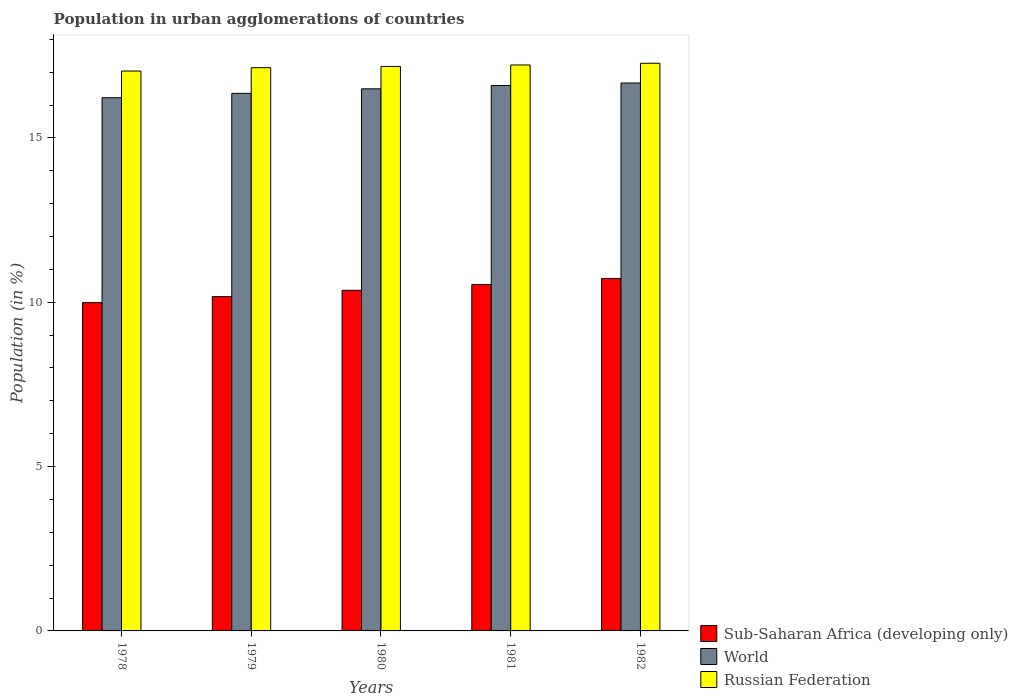Are the number of bars per tick equal to the number of legend labels?
Offer a terse response. Yes. Are the number of bars on each tick of the X-axis equal?
Offer a very short reply. Yes. What is the label of the 2nd group of bars from the left?
Make the answer very short. 1979. In how many cases, is the number of bars for a given year not equal to the number of legend labels?
Ensure brevity in your answer.  0. What is the percentage of population in urban agglomerations in World in 1982?
Keep it short and to the point. 16.67. Across all years, what is the maximum percentage of population in urban agglomerations in World?
Offer a terse response. 16.67. Across all years, what is the minimum percentage of population in urban agglomerations in Sub-Saharan Africa (developing only)?
Ensure brevity in your answer.  9.99. In which year was the percentage of population in urban agglomerations in World minimum?
Make the answer very short. 1978. What is the total percentage of population in urban agglomerations in World in the graph?
Give a very brief answer. 82.33. What is the difference between the percentage of population in urban agglomerations in Sub-Saharan Africa (developing only) in 1979 and that in 1981?
Keep it short and to the point. -0.37. What is the difference between the percentage of population in urban agglomerations in Sub-Saharan Africa (developing only) in 1982 and the percentage of population in urban agglomerations in Russian Federation in 1978?
Your answer should be compact. -6.31. What is the average percentage of population in urban agglomerations in Sub-Saharan Africa (developing only) per year?
Your answer should be compact. 10.36. In the year 1980, what is the difference between the percentage of population in urban agglomerations in World and percentage of population in urban agglomerations in Russian Federation?
Provide a short and direct response. -0.68. In how many years, is the percentage of population in urban agglomerations in Sub-Saharan Africa (developing only) greater than 6 %?
Offer a very short reply. 5. What is the ratio of the percentage of population in urban agglomerations in World in 1980 to that in 1982?
Provide a short and direct response. 0.99. Is the difference between the percentage of population in urban agglomerations in World in 1981 and 1982 greater than the difference between the percentage of population in urban agglomerations in Russian Federation in 1981 and 1982?
Make the answer very short. No. What is the difference between the highest and the second highest percentage of population in urban agglomerations in World?
Offer a very short reply. 0.08. What is the difference between the highest and the lowest percentage of population in urban agglomerations in Russian Federation?
Give a very brief answer. 0.24. In how many years, is the percentage of population in urban agglomerations in Sub-Saharan Africa (developing only) greater than the average percentage of population in urban agglomerations in Sub-Saharan Africa (developing only) taken over all years?
Provide a short and direct response. 3. What does the 2nd bar from the left in 1978 represents?
Your response must be concise. World. What does the 1st bar from the right in 1981 represents?
Make the answer very short. Russian Federation. How many bars are there?
Offer a terse response. 15. How many years are there in the graph?
Offer a very short reply. 5. What is the difference between two consecutive major ticks on the Y-axis?
Your answer should be compact. 5. Are the values on the major ticks of Y-axis written in scientific E-notation?
Your answer should be compact. No. How are the legend labels stacked?
Provide a succinct answer. Vertical. What is the title of the graph?
Provide a short and direct response. Population in urban agglomerations of countries. What is the label or title of the Y-axis?
Offer a terse response. Population (in %). What is the Population (in %) in Sub-Saharan Africa (developing only) in 1978?
Provide a short and direct response. 9.99. What is the Population (in %) of World in 1978?
Your answer should be very brief. 16.22. What is the Population (in %) of Russian Federation in 1978?
Keep it short and to the point. 17.03. What is the Population (in %) in Sub-Saharan Africa (developing only) in 1979?
Your answer should be very brief. 10.17. What is the Population (in %) of World in 1979?
Give a very brief answer. 16.35. What is the Population (in %) of Russian Federation in 1979?
Your response must be concise. 17.14. What is the Population (in %) in Sub-Saharan Africa (developing only) in 1980?
Your answer should be compact. 10.36. What is the Population (in %) of World in 1980?
Provide a short and direct response. 16.49. What is the Population (in %) of Russian Federation in 1980?
Provide a succinct answer. 17.17. What is the Population (in %) in Sub-Saharan Africa (developing only) in 1981?
Provide a succinct answer. 10.54. What is the Population (in %) in World in 1981?
Your response must be concise. 16.59. What is the Population (in %) of Russian Federation in 1981?
Your response must be concise. 17.22. What is the Population (in %) in Sub-Saharan Africa (developing only) in 1982?
Make the answer very short. 10.72. What is the Population (in %) in World in 1982?
Your answer should be compact. 16.67. What is the Population (in %) of Russian Federation in 1982?
Offer a very short reply. 17.27. Across all years, what is the maximum Population (in %) in Sub-Saharan Africa (developing only)?
Make the answer very short. 10.72. Across all years, what is the maximum Population (in %) in World?
Your answer should be very brief. 16.67. Across all years, what is the maximum Population (in %) in Russian Federation?
Offer a terse response. 17.27. Across all years, what is the minimum Population (in %) in Sub-Saharan Africa (developing only)?
Give a very brief answer. 9.99. Across all years, what is the minimum Population (in %) in World?
Give a very brief answer. 16.22. Across all years, what is the minimum Population (in %) in Russian Federation?
Offer a terse response. 17.03. What is the total Population (in %) in Sub-Saharan Africa (developing only) in the graph?
Provide a succinct answer. 51.79. What is the total Population (in %) in World in the graph?
Your answer should be very brief. 82.33. What is the total Population (in %) in Russian Federation in the graph?
Offer a very short reply. 85.83. What is the difference between the Population (in %) of Sub-Saharan Africa (developing only) in 1978 and that in 1979?
Your response must be concise. -0.18. What is the difference between the Population (in %) in World in 1978 and that in 1979?
Offer a very short reply. -0.13. What is the difference between the Population (in %) in Russian Federation in 1978 and that in 1979?
Ensure brevity in your answer.  -0.1. What is the difference between the Population (in %) in Sub-Saharan Africa (developing only) in 1978 and that in 1980?
Ensure brevity in your answer.  -0.37. What is the difference between the Population (in %) of World in 1978 and that in 1980?
Offer a terse response. -0.27. What is the difference between the Population (in %) in Russian Federation in 1978 and that in 1980?
Your response must be concise. -0.14. What is the difference between the Population (in %) in Sub-Saharan Africa (developing only) in 1978 and that in 1981?
Provide a succinct answer. -0.55. What is the difference between the Population (in %) in World in 1978 and that in 1981?
Give a very brief answer. -0.37. What is the difference between the Population (in %) of Russian Federation in 1978 and that in 1981?
Give a very brief answer. -0.19. What is the difference between the Population (in %) of Sub-Saharan Africa (developing only) in 1978 and that in 1982?
Ensure brevity in your answer.  -0.73. What is the difference between the Population (in %) in World in 1978 and that in 1982?
Your answer should be compact. -0.45. What is the difference between the Population (in %) of Russian Federation in 1978 and that in 1982?
Provide a short and direct response. -0.24. What is the difference between the Population (in %) in Sub-Saharan Africa (developing only) in 1979 and that in 1980?
Ensure brevity in your answer.  -0.19. What is the difference between the Population (in %) in World in 1979 and that in 1980?
Your response must be concise. -0.14. What is the difference between the Population (in %) of Russian Federation in 1979 and that in 1980?
Make the answer very short. -0.04. What is the difference between the Population (in %) in Sub-Saharan Africa (developing only) in 1979 and that in 1981?
Your answer should be compact. -0.37. What is the difference between the Population (in %) of World in 1979 and that in 1981?
Make the answer very short. -0.24. What is the difference between the Population (in %) in Russian Federation in 1979 and that in 1981?
Provide a succinct answer. -0.08. What is the difference between the Population (in %) of Sub-Saharan Africa (developing only) in 1979 and that in 1982?
Provide a succinct answer. -0.55. What is the difference between the Population (in %) of World in 1979 and that in 1982?
Keep it short and to the point. -0.32. What is the difference between the Population (in %) of Russian Federation in 1979 and that in 1982?
Your answer should be very brief. -0.13. What is the difference between the Population (in %) in Sub-Saharan Africa (developing only) in 1980 and that in 1981?
Keep it short and to the point. -0.18. What is the difference between the Population (in %) of World in 1980 and that in 1981?
Provide a short and direct response. -0.1. What is the difference between the Population (in %) of Russian Federation in 1980 and that in 1981?
Offer a very short reply. -0.04. What is the difference between the Population (in %) in Sub-Saharan Africa (developing only) in 1980 and that in 1982?
Your response must be concise. -0.36. What is the difference between the Population (in %) in World in 1980 and that in 1982?
Your answer should be compact. -0.18. What is the difference between the Population (in %) in Russian Federation in 1980 and that in 1982?
Give a very brief answer. -0.1. What is the difference between the Population (in %) in Sub-Saharan Africa (developing only) in 1981 and that in 1982?
Make the answer very short. -0.18. What is the difference between the Population (in %) of World in 1981 and that in 1982?
Ensure brevity in your answer.  -0.08. What is the difference between the Population (in %) of Russian Federation in 1981 and that in 1982?
Keep it short and to the point. -0.05. What is the difference between the Population (in %) of Sub-Saharan Africa (developing only) in 1978 and the Population (in %) of World in 1979?
Keep it short and to the point. -6.37. What is the difference between the Population (in %) of Sub-Saharan Africa (developing only) in 1978 and the Population (in %) of Russian Federation in 1979?
Your response must be concise. -7.15. What is the difference between the Population (in %) of World in 1978 and the Population (in %) of Russian Federation in 1979?
Your response must be concise. -0.91. What is the difference between the Population (in %) in Sub-Saharan Africa (developing only) in 1978 and the Population (in %) in World in 1980?
Offer a very short reply. -6.5. What is the difference between the Population (in %) in Sub-Saharan Africa (developing only) in 1978 and the Population (in %) in Russian Federation in 1980?
Your answer should be compact. -7.19. What is the difference between the Population (in %) in World in 1978 and the Population (in %) in Russian Federation in 1980?
Your answer should be very brief. -0.95. What is the difference between the Population (in %) in Sub-Saharan Africa (developing only) in 1978 and the Population (in %) in World in 1981?
Provide a short and direct response. -6.61. What is the difference between the Population (in %) of Sub-Saharan Africa (developing only) in 1978 and the Population (in %) of Russian Federation in 1981?
Your answer should be compact. -7.23. What is the difference between the Population (in %) of World in 1978 and the Population (in %) of Russian Federation in 1981?
Your answer should be very brief. -1. What is the difference between the Population (in %) in Sub-Saharan Africa (developing only) in 1978 and the Population (in %) in World in 1982?
Your answer should be compact. -6.68. What is the difference between the Population (in %) of Sub-Saharan Africa (developing only) in 1978 and the Population (in %) of Russian Federation in 1982?
Your answer should be very brief. -7.28. What is the difference between the Population (in %) in World in 1978 and the Population (in %) in Russian Federation in 1982?
Provide a succinct answer. -1.05. What is the difference between the Population (in %) of Sub-Saharan Africa (developing only) in 1979 and the Population (in %) of World in 1980?
Ensure brevity in your answer.  -6.32. What is the difference between the Population (in %) in Sub-Saharan Africa (developing only) in 1979 and the Population (in %) in Russian Federation in 1980?
Your answer should be very brief. -7. What is the difference between the Population (in %) of World in 1979 and the Population (in %) of Russian Federation in 1980?
Your answer should be compact. -0.82. What is the difference between the Population (in %) of Sub-Saharan Africa (developing only) in 1979 and the Population (in %) of World in 1981?
Ensure brevity in your answer.  -6.42. What is the difference between the Population (in %) in Sub-Saharan Africa (developing only) in 1979 and the Population (in %) in Russian Federation in 1981?
Offer a very short reply. -7.05. What is the difference between the Population (in %) in World in 1979 and the Population (in %) in Russian Federation in 1981?
Your response must be concise. -0.86. What is the difference between the Population (in %) of Sub-Saharan Africa (developing only) in 1979 and the Population (in %) of World in 1982?
Give a very brief answer. -6.5. What is the difference between the Population (in %) in Sub-Saharan Africa (developing only) in 1979 and the Population (in %) in Russian Federation in 1982?
Offer a terse response. -7.1. What is the difference between the Population (in %) in World in 1979 and the Population (in %) in Russian Federation in 1982?
Offer a very short reply. -0.92. What is the difference between the Population (in %) of Sub-Saharan Africa (developing only) in 1980 and the Population (in %) of World in 1981?
Provide a short and direct response. -6.23. What is the difference between the Population (in %) in Sub-Saharan Africa (developing only) in 1980 and the Population (in %) in Russian Federation in 1981?
Ensure brevity in your answer.  -6.86. What is the difference between the Population (in %) of World in 1980 and the Population (in %) of Russian Federation in 1981?
Provide a succinct answer. -0.73. What is the difference between the Population (in %) in Sub-Saharan Africa (developing only) in 1980 and the Population (in %) in World in 1982?
Provide a short and direct response. -6.31. What is the difference between the Population (in %) of Sub-Saharan Africa (developing only) in 1980 and the Population (in %) of Russian Federation in 1982?
Provide a succinct answer. -6.91. What is the difference between the Population (in %) of World in 1980 and the Population (in %) of Russian Federation in 1982?
Ensure brevity in your answer.  -0.78. What is the difference between the Population (in %) in Sub-Saharan Africa (developing only) in 1981 and the Population (in %) in World in 1982?
Give a very brief answer. -6.13. What is the difference between the Population (in %) in Sub-Saharan Africa (developing only) in 1981 and the Population (in %) in Russian Federation in 1982?
Offer a terse response. -6.73. What is the difference between the Population (in %) in World in 1981 and the Population (in %) in Russian Federation in 1982?
Provide a short and direct response. -0.68. What is the average Population (in %) in Sub-Saharan Africa (developing only) per year?
Provide a short and direct response. 10.36. What is the average Population (in %) in World per year?
Provide a short and direct response. 16.47. What is the average Population (in %) of Russian Federation per year?
Ensure brevity in your answer.  17.17. In the year 1978, what is the difference between the Population (in %) of Sub-Saharan Africa (developing only) and Population (in %) of World?
Your answer should be compact. -6.23. In the year 1978, what is the difference between the Population (in %) of Sub-Saharan Africa (developing only) and Population (in %) of Russian Federation?
Provide a short and direct response. -7.04. In the year 1978, what is the difference between the Population (in %) of World and Population (in %) of Russian Federation?
Your answer should be very brief. -0.81. In the year 1979, what is the difference between the Population (in %) in Sub-Saharan Africa (developing only) and Population (in %) in World?
Offer a very short reply. -6.18. In the year 1979, what is the difference between the Population (in %) in Sub-Saharan Africa (developing only) and Population (in %) in Russian Federation?
Your response must be concise. -6.96. In the year 1979, what is the difference between the Population (in %) in World and Population (in %) in Russian Federation?
Ensure brevity in your answer.  -0.78. In the year 1980, what is the difference between the Population (in %) in Sub-Saharan Africa (developing only) and Population (in %) in World?
Offer a terse response. -6.13. In the year 1980, what is the difference between the Population (in %) in Sub-Saharan Africa (developing only) and Population (in %) in Russian Federation?
Offer a very short reply. -6.81. In the year 1980, what is the difference between the Population (in %) of World and Population (in %) of Russian Federation?
Ensure brevity in your answer.  -0.68. In the year 1981, what is the difference between the Population (in %) in Sub-Saharan Africa (developing only) and Population (in %) in World?
Your answer should be very brief. -6.05. In the year 1981, what is the difference between the Population (in %) in Sub-Saharan Africa (developing only) and Population (in %) in Russian Federation?
Ensure brevity in your answer.  -6.68. In the year 1981, what is the difference between the Population (in %) of World and Population (in %) of Russian Federation?
Ensure brevity in your answer.  -0.62. In the year 1982, what is the difference between the Population (in %) in Sub-Saharan Africa (developing only) and Population (in %) in World?
Offer a terse response. -5.95. In the year 1982, what is the difference between the Population (in %) in Sub-Saharan Africa (developing only) and Population (in %) in Russian Federation?
Your response must be concise. -6.55. In the year 1982, what is the difference between the Population (in %) in World and Population (in %) in Russian Federation?
Keep it short and to the point. -0.6. What is the ratio of the Population (in %) in Sub-Saharan Africa (developing only) in 1978 to that in 1979?
Your response must be concise. 0.98. What is the ratio of the Population (in %) in Sub-Saharan Africa (developing only) in 1978 to that in 1980?
Provide a succinct answer. 0.96. What is the ratio of the Population (in %) of World in 1978 to that in 1980?
Offer a terse response. 0.98. What is the ratio of the Population (in %) in Russian Federation in 1978 to that in 1980?
Your response must be concise. 0.99. What is the ratio of the Population (in %) of Sub-Saharan Africa (developing only) in 1978 to that in 1981?
Offer a terse response. 0.95. What is the ratio of the Population (in %) in World in 1978 to that in 1981?
Your response must be concise. 0.98. What is the ratio of the Population (in %) of Russian Federation in 1978 to that in 1981?
Keep it short and to the point. 0.99. What is the ratio of the Population (in %) of Sub-Saharan Africa (developing only) in 1978 to that in 1982?
Your response must be concise. 0.93. What is the ratio of the Population (in %) of World in 1978 to that in 1982?
Your response must be concise. 0.97. What is the ratio of the Population (in %) in Russian Federation in 1978 to that in 1982?
Make the answer very short. 0.99. What is the ratio of the Population (in %) of Sub-Saharan Africa (developing only) in 1979 to that in 1980?
Keep it short and to the point. 0.98. What is the ratio of the Population (in %) in Sub-Saharan Africa (developing only) in 1979 to that in 1981?
Your answer should be compact. 0.97. What is the ratio of the Population (in %) in World in 1979 to that in 1981?
Your answer should be compact. 0.99. What is the ratio of the Population (in %) in Russian Federation in 1979 to that in 1981?
Keep it short and to the point. 1. What is the ratio of the Population (in %) in Sub-Saharan Africa (developing only) in 1979 to that in 1982?
Offer a very short reply. 0.95. What is the ratio of the Population (in %) of World in 1979 to that in 1982?
Your response must be concise. 0.98. What is the ratio of the Population (in %) of Sub-Saharan Africa (developing only) in 1980 to that in 1981?
Offer a very short reply. 0.98. What is the ratio of the Population (in %) of Sub-Saharan Africa (developing only) in 1980 to that in 1982?
Ensure brevity in your answer.  0.97. What is the ratio of the Population (in %) of World in 1980 to that in 1982?
Your answer should be very brief. 0.99. What is the ratio of the Population (in %) of Russian Federation in 1980 to that in 1982?
Your answer should be very brief. 0.99. What is the ratio of the Population (in %) in Sub-Saharan Africa (developing only) in 1981 to that in 1982?
Provide a succinct answer. 0.98. What is the ratio of the Population (in %) of World in 1981 to that in 1982?
Keep it short and to the point. 1. What is the difference between the highest and the second highest Population (in %) in Sub-Saharan Africa (developing only)?
Make the answer very short. 0.18. What is the difference between the highest and the second highest Population (in %) in World?
Your answer should be compact. 0.08. What is the difference between the highest and the second highest Population (in %) of Russian Federation?
Ensure brevity in your answer.  0.05. What is the difference between the highest and the lowest Population (in %) in Sub-Saharan Africa (developing only)?
Provide a short and direct response. 0.73. What is the difference between the highest and the lowest Population (in %) of World?
Offer a very short reply. 0.45. What is the difference between the highest and the lowest Population (in %) of Russian Federation?
Your answer should be compact. 0.24. 